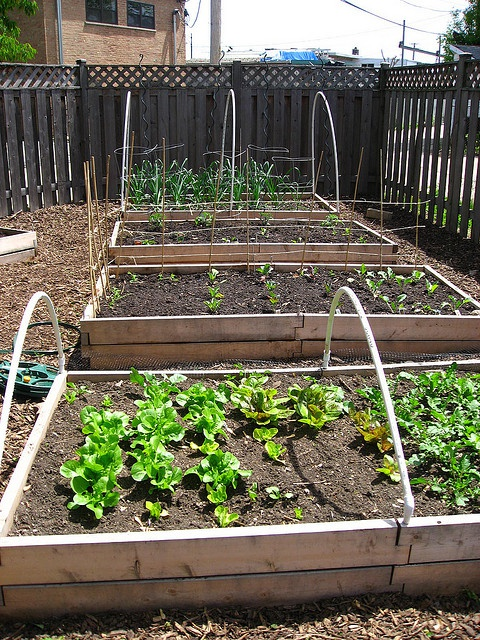Describe the objects in this image and their specific colors. I can see various objects in this image with different colors. 